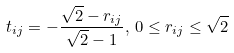Convert formula to latex. <formula><loc_0><loc_0><loc_500><loc_500>t _ { i j } = - \frac { \sqrt { 2 } - r _ { i j } } { \sqrt { 2 } - 1 } , \, 0 \leq r _ { i j } \leq \sqrt { 2 }</formula> 